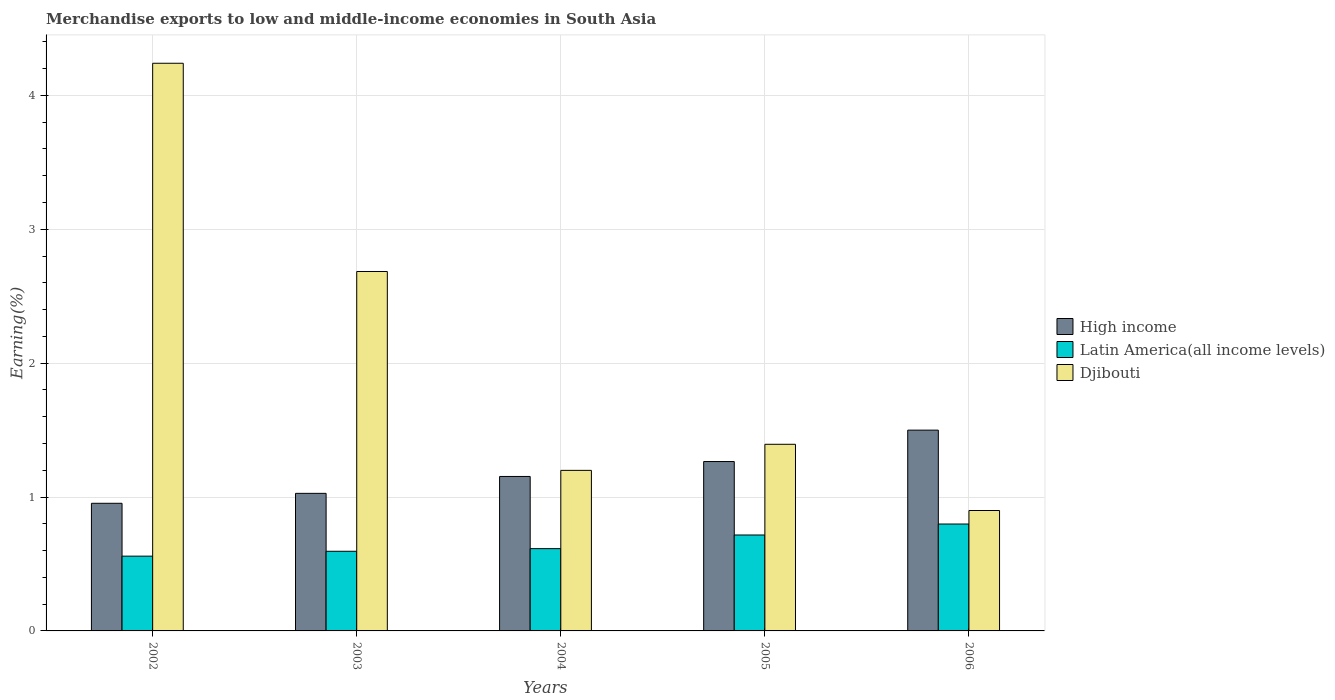How many groups of bars are there?
Provide a short and direct response. 5. Are the number of bars on each tick of the X-axis equal?
Your response must be concise. Yes. How many bars are there on the 4th tick from the right?
Ensure brevity in your answer.  3. What is the percentage of amount earned from merchandise exports in High income in 2005?
Ensure brevity in your answer.  1.27. Across all years, what is the maximum percentage of amount earned from merchandise exports in High income?
Your response must be concise. 1.5. Across all years, what is the minimum percentage of amount earned from merchandise exports in Latin America(all income levels)?
Ensure brevity in your answer.  0.56. What is the total percentage of amount earned from merchandise exports in Latin America(all income levels) in the graph?
Keep it short and to the point. 3.28. What is the difference between the percentage of amount earned from merchandise exports in High income in 2004 and that in 2006?
Provide a succinct answer. -0.35. What is the difference between the percentage of amount earned from merchandise exports in Latin America(all income levels) in 2003 and the percentage of amount earned from merchandise exports in High income in 2006?
Offer a very short reply. -0.9. What is the average percentage of amount earned from merchandise exports in Latin America(all income levels) per year?
Your answer should be very brief. 0.66. In the year 2004, what is the difference between the percentage of amount earned from merchandise exports in High income and percentage of amount earned from merchandise exports in Latin America(all income levels)?
Keep it short and to the point. 0.54. In how many years, is the percentage of amount earned from merchandise exports in Latin America(all income levels) greater than 4.2 %?
Provide a succinct answer. 0. What is the ratio of the percentage of amount earned from merchandise exports in High income in 2003 to that in 2005?
Offer a very short reply. 0.81. Is the difference between the percentage of amount earned from merchandise exports in High income in 2004 and 2006 greater than the difference between the percentage of amount earned from merchandise exports in Latin America(all income levels) in 2004 and 2006?
Give a very brief answer. No. What is the difference between the highest and the second highest percentage of amount earned from merchandise exports in Djibouti?
Ensure brevity in your answer.  1.56. What is the difference between the highest and the lowest percentage of amount earned from merchandise exports in Djibouti?
Offer a terse response. 3.34. Is the sum of the percentage of amount earned from merchandise exports in Latin America(all income levels) in 2004 and 2005 greater than the maximum percentage of amount earned from merchandise exports in Djibouti across all years?
Your response must be concise. No. What does the 2nd bar from the left in 2005 represents?
Your answer should be compact. Latin America(all income levels). What does the 3rd bar from the right in 2002 represents?
Give a very brief answer. High income. How many bars are there?
Keep it short and to the point. 15. Are all the bars in the graph horizontal?
Offer a terse response. No. Does the graph contain any zero values?
Provide a short and direct response. No. Does the graph contain grids?
Your answer should be very brief. Yes. Where does the legend appear in the graph?
Make the answer very short. Center right. How many legend labels are there?
Make the answer very short. 3. How are the legend labels stacked?
Your answer should be very brief. Vertical. What is the title of the graph?
Provide a succinct answer. Merchandise exports to low and middle-income economies in South Asia. What is the label or title of the Y-axis?
Ensure brevity in your answer.  Earning(%). What is the Earning(%) of High income in 2002?
Offer a very short reply. 0.95. What is the Earning(%) of Latin America(all income levels) in 2002?
Make the answer very short. 0.56. What is the Earning(%) of Djibouti in 2002?
Provide a short and direct response. 4.24. What is the Earning(%) in High income in 2003?
Provide a succinct answer. 1.03. What is the Earning(%) of Latin America(all income levels) in 2003?
Give a very brief answer. 0.59. What is the Earning(%) of Djibouti in 2003?
Ensure brevity in your answer.  2.68. What is the Earning(%) in High income in 2004?
Your response must be concise. 1.15. What is the Earning(%) of Latin America(all income levels) in 2004?
Offer a terse response. 0.61. What is the Earning(%) in Djibouti in 2004?
Make the answer very short. 1.2. What is the Earning(%) in High income in 2005?
Provide a succinct answer. 1.27. What is the Earning(%) in Latin America(all income levels) in 2005?
Make the answer very short. 0.72. What is the Earning(%) in Djibouti in 2005?
Offer a terse response. 1.39. What is the Earning(%) of High income in 2006?
Offer a very short reply. 1.5. What is the Earning(%) of Latin America(all income levels) in 2006?
Provide a succinct answer. 0.8. What is the Earning(%) in Djibouti in 2006?
Offer a terse response. 0.9. Across all years, what is the maximum Earning(%) in High income?
Your response must be concise. 1.5. Across all years, what is the maximum Earning(%) of Latin America(all income levels)?
Your answer should be very brief. 0.8. Across all years, what is the maximum Earning(%) of Djibouti?
Make the answer very short. 4.24. Across all years, what is the minimum Earning(%) in High income?
Provide a succinct answer. 0.95. Across all years, what is the minimum Earning(%) in Latin America(all income levels)?
Make the answer very short. 0.56. Across all years, what is the minimum Earning(%) in Djibouti?
Provide a short and direct response. 0.9. What is the total Earning(%) in High income in the graph?
Give a very brief answer. 5.9. What is the total Earning(%) of Latin America(all income levels) in the graph?
Your answer should be very brief. 3.28. What is the total Earning(%) of Djibouti in the graph?
Offer a very short reply. 10.42. What is the difference between the Earning(%) of High income in 2002 and that in 2003?
Provide a succinct answer. -0.07. What is the difference between the Earning(%) of Latin America(all income levels) in 2002 and that in 2003?
Your response must be concise. -0.04. What is the difference between the Earning(%) in Djibouti in 2002 and that in 2003?
Keep it short and to the point. 1.56. What is the difference between the Earning(%) of High income in 2002 and that in 2004?
Provide a short and direct response. -0.2. What is the difference between the Earning(%) in Latin America(all income levels) in 2002 and that in 2004?
Give a very brief answer. -0.06. What is the difference between the Earning(%) of Djibouti in 2002 and that in 2004?
Your answer should be very brief. 3.04. What is the difference between the Earning(%) in High income in 2002 and that in 2005?
Provide a succinct answer. -0.31. What is the difference between the Earning(%) of Latin America(all income levels) in 2002 and that in 2005?
Offer a very short reply. -0.16. What is the difference between the Earning(%) in Djibouti in 2002 and that in 2005?
Your answer should be very brief. 2.85. What is the difference between the Earning(%) of High income in 2002 and that in 2006?
Ensure brevity in your answer.  -0.55. What is the difference between the Earning(%) in Latin America(all income levels) in 2002 and that in 2006?
Keep it short and to the point. -0.24. What is the difference between the Earning(%) of Djibouti in 2002 and that in 2006?
Make the answer very short. 3.34. What is the difference between the Earning(%) of High income in 2003 and that in 2004?
Keep it short and to the point. -0.13. What is the difference between the Earning(%) in Latin America(all income levels) in 2003 and that in 2004?
Give a very brief answer. -0.02. What is the difference between the Earning(%) in Djibouti in 2003 and that in 2004?
Offer a terse response. 1.49. What is the difference between the Earning(%) in High income in 2003 and that in 2005?
Your answer should be compact. -0.24. What is the difference between the Earning(%) of Latin America(all income levels) in 2003 and that in 2005?
Your answer should be very brief. -0.12. What is the difference between the Earning(%) in Djibouti in 2003 and that in 2005?
Ensure brevity in your answer.  1.29. What is the difference between the Earning(%) of High income in 2003 and that in 2006?
Ensure brevity in your answer.  -0.47. What is the difference between the Earning(%) in Latin America(all income levels) in 2003 and that in 2006?
Your answer should be very brief. -0.2. What is the difference between the Earning(%) of Djibouti in 2003 and that in 2006?
Provide a succinct answer. 1.79. What is the difference between the Earning(%) of High income in 2004 and that in 2005?
Provide a succinct answer. -0.11. What is the difference between the Earning(%) in Latin America(all income levels) in 2004 and that in 2005?
Your answer should be very brief. -0.1. What is the difference between the Earning(%) of Djibouti in 2004 and that in 2005?
Provide a succinct answer. -0.19. What is the difference between the Earning(%) of High income in 2004 and that in 2006?
Ensure brevity in your answer.  -0.35. What is the difference between the Earning(%) of Latin America(all income levels) in 2004 and that in 2006?
Provide a succinct answer. -0.18. What is the difference between the Earning(%) of Djibouti in 2004 and that in 2006?
Provide a succinct answer. 0.3. What is the difference between the Earning(%) of High income in 2005 and that in 2006?
Offer a terse response. -0.23. What is the difference between the Earning(%) of Latin America(all income levels) in 2005 and that in 2006?
Provide a succinct answer. -0.08. What is the difference between the Earning(%) in Djibouti in 2005 and that in 2006?
Make the answer very short. 0.49. What is the difference between the Earning(%) in High income in 2002 and the Earning(%) in Latin America(all income levels) in 2003?
Your response must be concise. 0.36. What is the difference between the Earning(%) in High income in 2002 and the Earning(%) in Djibouti in 2003?
Offer a very short reply. -1.73. What is the difference between the Earning(%) in Latin America(all income levels) in 2002 and the Earning(%) in Djibouti in 2003?
Offer a very short reply. -2.13. What is the difference between the Earning(%) in High income in 2002 and the Earning(%) in Latin America(all income levels) in 2004?
Keep it short and to the point. 0.34. What is the difference between the Earning(%) of High income in 2002 and the Earning(%) of Djibouti in 2004?
Your answer should be compact. -0.25. What is the difference between the Earning(%) of Latin America(all income levels) in 2002 and the Earning(%) of Djibouti in 2004?
Your answer should be compact. -0.64. What is the difference between the Earning(%) in High income in 2002 and the Earning(%) in Latin America(all income levels) in 2005?
Your answer should be very brief. 0.24. What is the difference between the Earning(%) in High income in 2002 and the Earning(%) in Djibouti in 2005?
Provide a short and direct response. -0.44. What is the difference between the Earning(%) in Latin America(all income levels) in 2002 and the Earning(%) in Djibouti in 2005?
Your answer should be compact. -0.84. What is the difference between the Earning(%) of High income in 2002 and the Earning(%) of Latin America(all income levels) in 2006?
Your response must be concise. 0.15. What is the difference between the Earning(%) in High income in 2002 and the Earning(%) in Djibouti in 2006?
Offer a very short reply. 0.05. What is the difference between the Earning(%) in Latin America(all income levels) in 2002 and the Earning(%) in Djibouti in 2006?
Ensure brevity in your answer.  -0.34. What is the difference between the Earning(%) of High income in 2003 and the Earning(%) of Latin America(all income levels) in 2004?
Ensure brevity in your answer.  0.41. What is the difference between the Earning(%) in High income in 2003 and the Earning(%) in Djibouti in 2004?
Offer a terse response. -0.17. What is the difference between the Earning(%) of Latin America(all income levels) in 2003 and the Earning(%) of Djibouti in 2004?
Keep it short and to the point. -0.6. What is the difference between the Earning(%) in High income in 2003 and the Earning(%) in Latin America(all income levels) in 2005?
Make the answer very short. 0.31. What is the difference between the Earning(%) in High income in 2003 and the Earning(%) in Djibouti in 2005?
Provide a short and direct response. -0.37. What is the difference between the Earning(%) in Latin America(all income levels) in 2003 and the Earning(%) in Djibouti in 2005?
Your answer should be very brief. -0.8. What is the difference between the Earning(%) in High income in 2003 and the Earning(%) in Latin America(all income levels) in 2006?
Your answer should be very brief. 0.23. What is the difference between the Earning(%) in High income in 2003 and the Earning(%) in Djibouti in 2006?
Make the answer very short. 0.13. What is the difference between the Earning(%) of Latin America(all income levels) in 2003 and the Earning(%) of Djibouti in 2006?
Provide a short and direct response. -0.3. What is the difference between the Earning(%) in High income in 2004 and the Earning(%) in Latin America(all income levels) in 2005?
Provide a short and direct response. 0.44. What is the difference between the Earning(%) of High income in 2004 and the Earning(%) of Djibouti in 2005?
Offer a terse response. -0.24. What is the difference between the Earning(%) of Latin America(all income levels) in 2004 and the Earning(%) of Djibouti in 2005?
Give a very brief answer. -0.78. What is the difference between the Earning(%) in High income in 2004 and the Earning(%) in Latin America(all income levels) in 2006?
Your answer should be compact. 0.36. What is the difference between the Earning(%) in High income in 2004 and the Earning(%) in Djibouti in 2006?
Offer a terse response. 0.25. What is the difference between the Earning(%) in Latin America(all income levels) in 2004 and the Earning(%) in Djibouti in 2006?
Your answer should be compact. -0.28. What is the difference between the Earning(%) of High income in 2005 and the Earning(%) of Latin America(all income levels) in 2006?
Your answer should be very brief. 0.47. What is the difference between the Earning(%) in High income in 2005 and the Earning(%) in Djibouti in 2006?
Keep it short and to the point. 0.37. What is the difference between the Earning(%) in Latin America(all income levels) in 2005 and the Earning(%) in Djibouti in 2006?
Provide a succinct answer. -0.18. What is the average Earning(%) of High income per year?
Offer a very short reply. 1.18. What is the average Earning(%) of Latin America(all income levels) per year?
Make the answer very short. 0.66. What is the average Earning(%) of Djibouti per year?
Provide a short and direct response. 2.08. In the year 2002, what is the difference between the Earning(%) of High income and Earning(%) of Latin America(all income levels)?
Your answer should be very brief. 0.39. In the year 2002, what is the difference between the Earning(%) of High income and Earning(%) of Djibouti?
Your answer should be compact. -3.29. In the year 2002, what is the difference between the Earning(%) in Latin America(all income levels) and Earning(%) in Djibouti?
Keep it short and to the point. -3.68. In the year 2003, what is the difference between the Earning(%) of High income and Earning(%) of Latin America(all income levels)?
Provide a succinct answer. 0.43. In the year 2003, what is the difference between the Earning(%) in High income and Earning(%) in Djibouti?
Provide a short and direct response. -1.66. In the year 2003, what is the difference between the Earning(%) of Latin America(all income levels) and Earning(%) of Djibouti?
Your answer should be very brief. -2.09. In the year 2004, what is the difference between the Earning(%) in High income and Earning(%) in Latin America(all income levels)?
Your response must be concise. 0.54. In the year 2004, what is the difference between the Earning(%) in High income and Earning(%) in Djibouti?
Your response must be concise. -0.05. In the year 2004, what is the difference between the Earning(%) in Latin America(all income levels) and Earning(%) in Djibouti?
Keep it short and to the point. -0.58. In the year 2005, what is the difference between the Earning(%) of High income and Earning(%) of Latin America(all income levels)?
Your answer should be compact. 0.55. In the year 2005, what is the difference between the Earning(%) in High income and Earning(%) in Djibouti?
Offer a terse response. -0.13. In the year 2005, what is the difference between the Earning(%) in Latin America(all income levels) and Earning(%) in Djibouti?
Your answer should be very brief. -0.68. In the year 2006, what is the difference between the Earning(%) in High income and Earning(%) in Latin America(all income levels)?
Your response must be concise. 0.7. In the year 2006, what is the difference between the Earning(%) in High income and Earning(%) in Djibouti?
Make the answer very short. 0.6. In the year 2006, what is the difference between the Earning(%) of Latin America(all income levels) and Earning(%) of Djibouti?
Your response must be concise. -0.1. What is the ratio of the Earning(%) in High income in 2002 to that in 2003?
Provide a short and direct response. 0.93. What is the ratio of the Earning(%) in Latin America(all income levels) in 2002 to that in 2003?
Make the answer very short. 0.94. What is the ratio of the Earning(%) of Djibouti in 2002 to that in 2003?
Provide a short and direct response. 1.58. What is the ratio of the Earning(%) in High income in 2002 to that in 2004?
Make the answer very short. 0.83. What is the ratio of the Earning(%) of Latin America(all income levels) in 2002 to that in 2004?
Keep it short and to the point. 0.91. What is the ratio of the Earning(%) of Djibouti in 2002 to that in 2004?
Your answer should be very brief. 3.54. What is the ratio of the Earning(%) of High income in 2002 to that in 2005?
Offer a terse response. 0.75. What is the ratio of the Earning(%) of Latin America(all income levels) in 2002 to that in 2005?
Your answer should be compact. 0.78. What is the ratio of the Earning(%) of Djibouti in 2002 to that in 2005?
Make the answer very short. 3.04. What is the ratio of the Earning(%) in High income in 2002 to that in 2006?
Keep it short and to the point. 0.64. What is the ratio of the Earning(%) of Latin America(all income levels) in 2002 to that in 2006?
Keep it short and to the point. 0.7. What is the ratio of the Earning(%) in Djibouti in 2002 to that in 2006?
Your answer should be compact. 4.71. What is the ratio of the Earning(%) in High income in 2003 to that in 2004?
Provide a short and direct response. 0.89. What is the ratio of the Earning(%) of Latin America(all income levels) in 2003 to that in 2004?
Give a very brief answer. 0.97. What is the ratio of the Earning(%) of Djibouti in 2003 to that in 2004?
Your answer should be compact. 2.24. What is the ratio of the Earning(%) of High income in 2003 to that in 2005?
Ensure brevity in your answer.  0.81. What is the ratio of the Earning(%) of Latin America(all income levels) in 2003 to that in 2005?
Provide a succinct answer. 0.83. What is the ratio of the Earning(%) of Djibouti in 2003 to that in 2005?
Ensure brevity in your answer.  1.93. What is the ratio of the Earning(%) in High income in 2003 to that in 2006?
Make the answer very short. 0.69. What is the ratio of the Earning(%) in Latin America(all income levels) in 2003 to that in 2006?
Your answer should be very brief. 0.75. What is the ratio of the Earning(%) of Djibouti in 2003 to that in 2006?
Keep it short and to the point. 2.99. What is the ratio of the Earning(%) of High income in 2004 to that in 2005?
Give a very brief answer. 0.91. What is the ratio of the Earning(%) of Latin America(all income levels) in 2004 to that in 2005?
Provide a short and direct response. 0.86. What is the ratio of the Earning(%) in Djibouti in 2004 to that in 2005?
Your answer should be compact. 0.86. What is the ratio of the Earning(%) of High income in 2004 to that in 2006?
Provide a succinct answer. 0.77. What is the ratio of the Earning(%) in Latin America(all income levels) in 2004 to that in 2006?
Your answer should be very brief. 0.77. What is the ratio of the Earning(%) in Djibouti in 2004 to that in 2006?
Provide a short and direct response. 1.33. What is the ratio of the Earning(%) in High income in 2005 to that in 2006?
Provide a succinct answer. 0.84. What is the ratio of the Earning(%) of Latin America(all income levels) in 2005 to that in 2006?
Provide a short and direct response. 0.9. What is the ratio of the Earning(%) in Djibouti in 2005 to that in 2006?
Give a very brief answer. 1.55. What is the difference between the highest and the second highest Earning(%) in High income?
Provide a short and direct response. 0.23. What is the difference between the highest and the second highest Earning(%) of Latin America(all income levels)?
Keep it short and to the point. 0.08. What is the difference between the highest and the second highest Earning(%) in Djibouti?
Provide a short and direct response. 1.56. What is the difference between the highest and the lowest Earning(%) of High income?
Make the answer very short. 0.55. What is the difference between the highest and the lowest Earning(%) of Latin America(all income levels)?
Provide a succinct answer. 0.24. What is the difference between the highest and the lowest Earning(%) of Djibouti?
Provide a short and direct response. 3.34. 